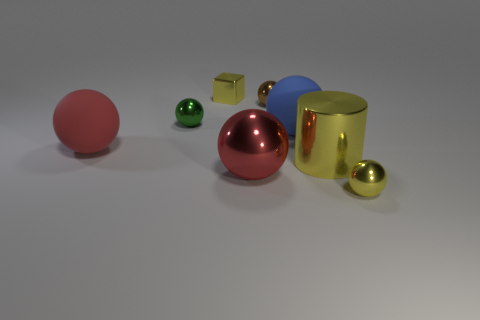There is a large object that is to the left of the tiny green metallic sphere; does it have the same color as the big metal sphere?
Keep it short and to the point. Yes. What is the material of the blue object that is the same shape as the small green metallic object?
Your answer should be very brief. Rubber. There is a small yellow thing behind the large red metal object; what is its material?
Give a very brief answer. Metal. There is a metal cylinder; is it the same color as the tiny shiny thing that is in front of the red metal ball?
Your answer should be compact. Yes. What number of objects are either small yellow metallic things right of the brown shiny ball or shiny spheres that are behind the green sphere?
Make the answer very short. 2. There is a ball that is both on the left side of the yellow shiny cylinder and in front of the large yellow cylinder; what color is it?
Make the answer very short. Red. Is the number of yellow metal things greater than the number of metallic things?
Your response must be concise. No. There is a red thing that is in front of the red matte ball; is it the same shape as the green thing?
Ensure brevity in your answer.  Yes. What number of matte things are either balls or small yellow balls?
Keep it short and to the point. 2. Is there a large yellow thing that has the same material as the green thing?
Keep it short and to the point. Yes. 